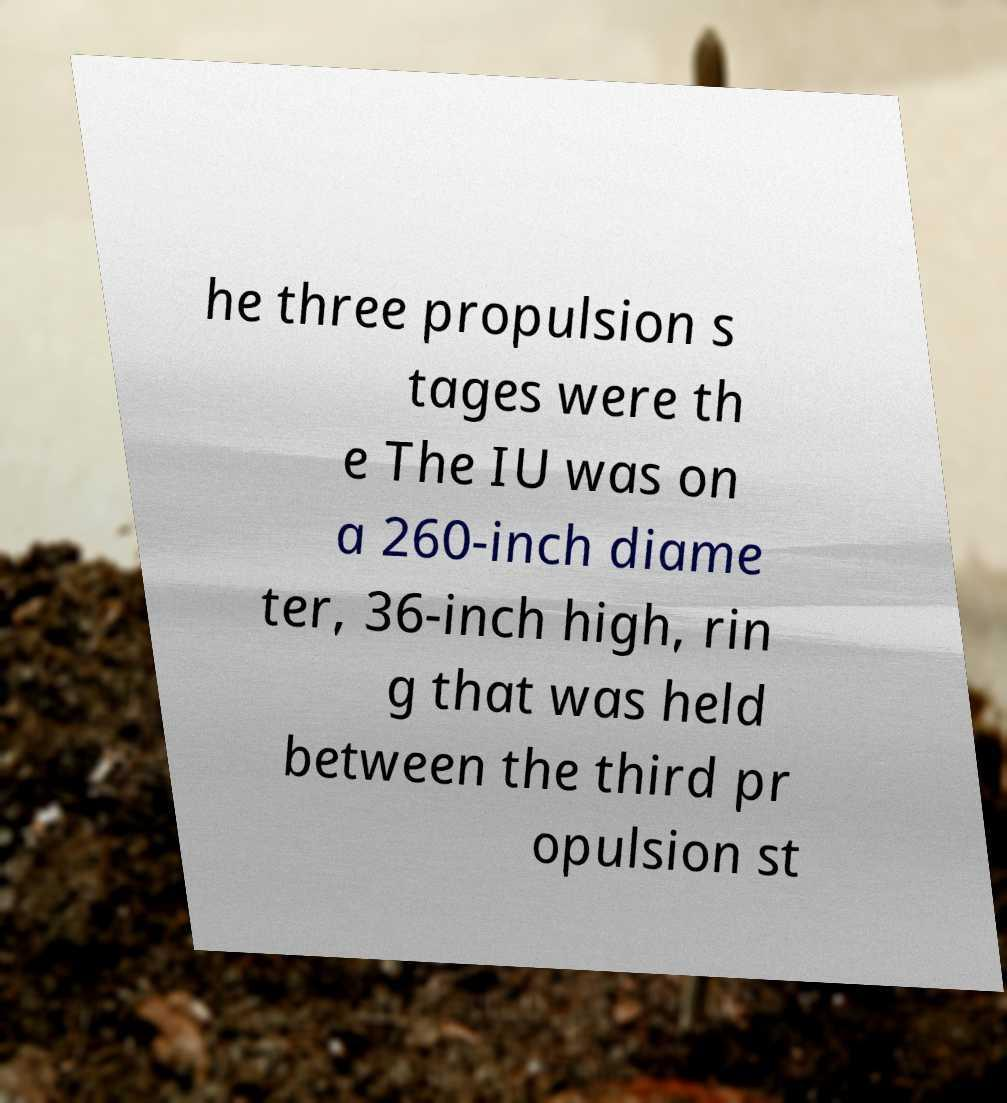Could you assist in decoding the text presented in this image and type it out clearly? he three propulsion s tages were th e The IU was on a 260-inch diame ter, 36-inch high, rin g that was held between the third pr opulsion st 